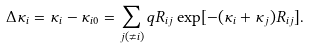<formula> <loc_0><loc_0><loc_500><loc_500>\Delta \kappa _ { i } = \kappa _ { i } - \kappa _ { i 0 } = \sum _ { j ( \neq i ) } q R _ { i j } \exp [ { - ( \kappa _ { i } + \kappa _ { j } ) R _ { i j } } ] .</formula> 